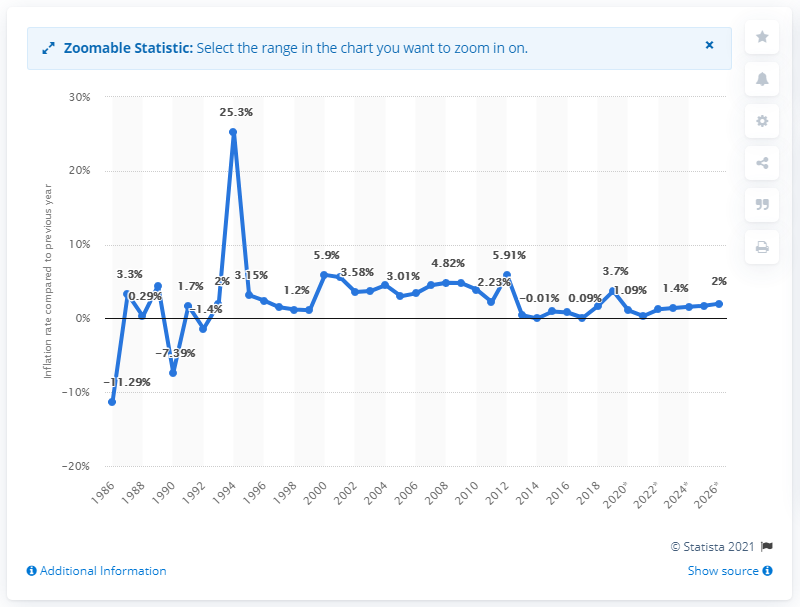What was the inflation rate in Comoros in 2019? In 2019, the inflation rate in Comoros was 3.7%. This rate indicates a moderate increase in prices compared to other years, suggesting a relatively stable economic situation that year. 